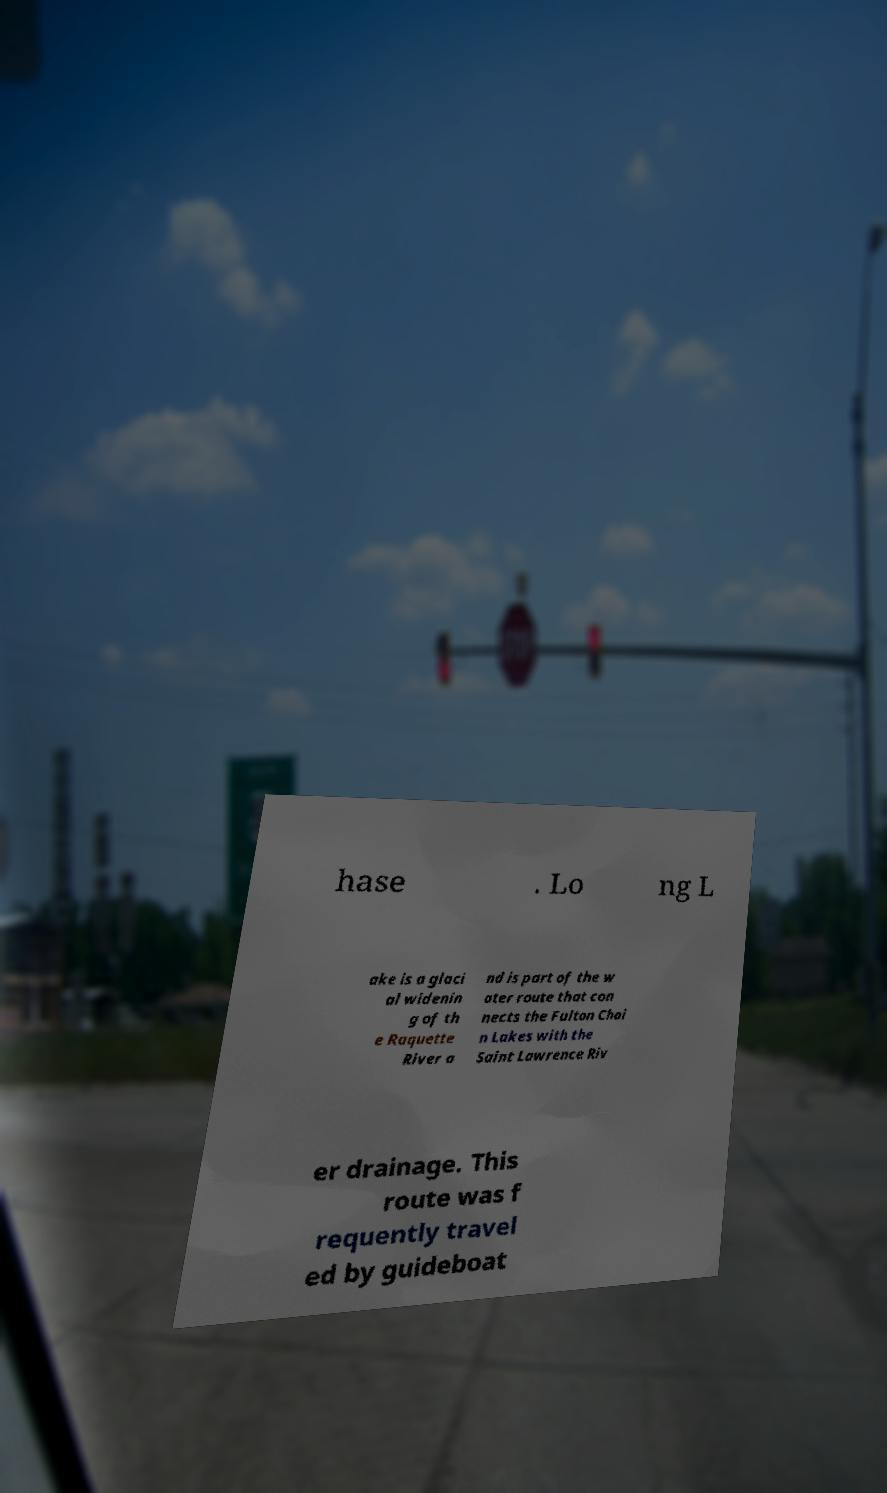Please identify and transcribe the text found in this image. hase . Lo ng L ake is a glaci al widenin g of th e Raquette River a nd is part of the w ater route that con nects the Fulton Chai n Lakes with the Saint Lawrence Riv er drainage. This route was f requently travel ed by guideboat 